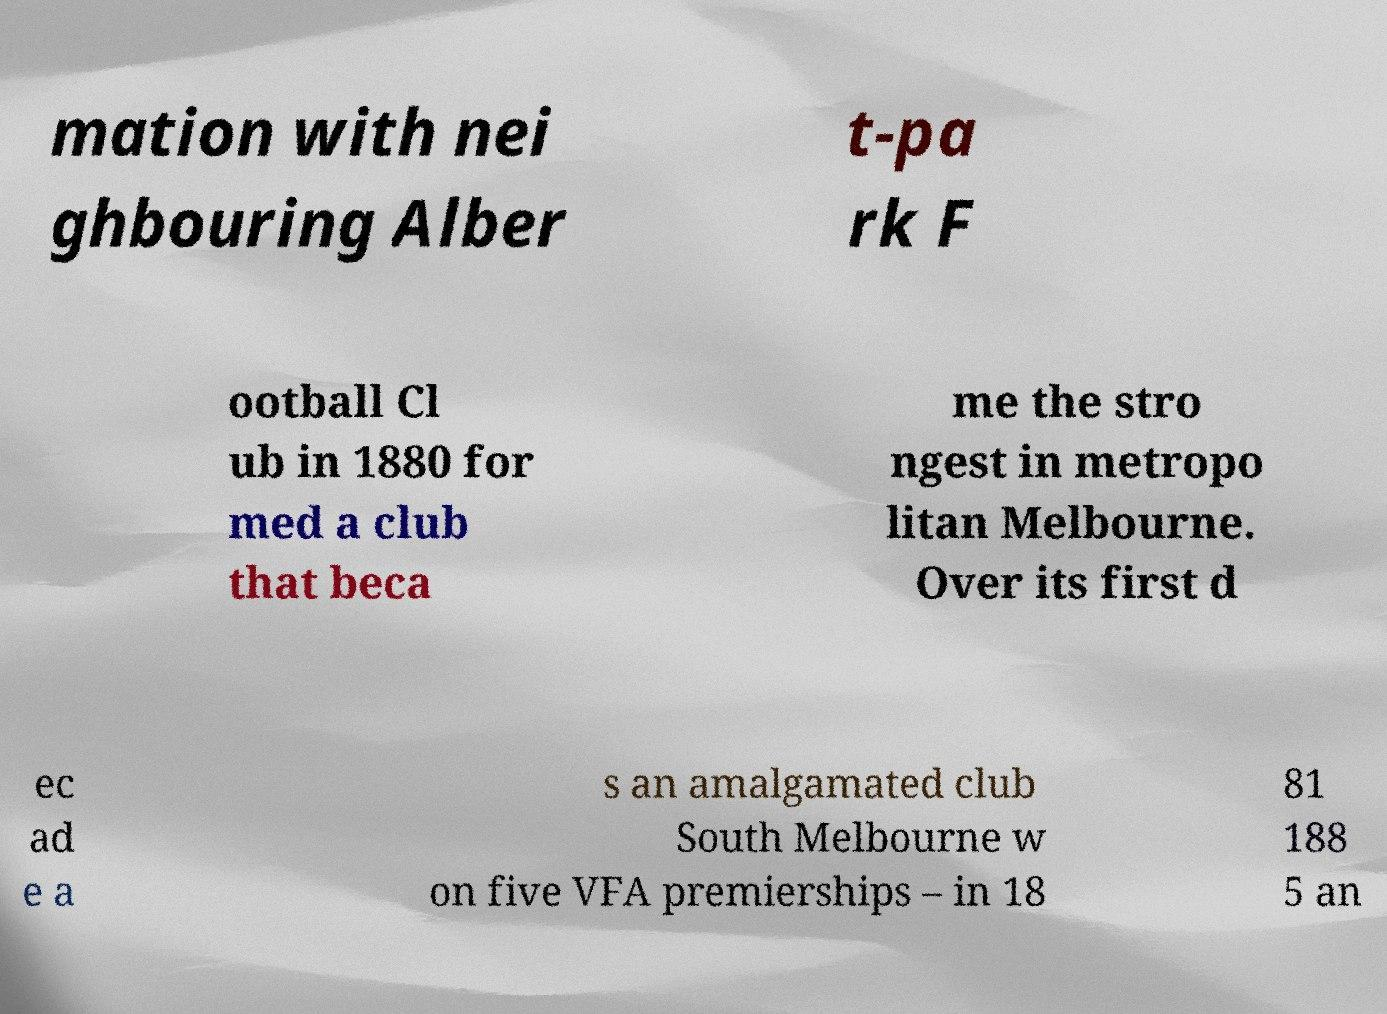Could you extract and type out the text from this image? mation with nei ghbouring Alber t-pa rk F ootball Cl ub in 1880 for med a club that beca me the stro ngest in metropo litan Melbourne. Over its first d ec ad e a s an amalgamated club South Melbourne w on five VFA premierships – in 18 81 188 5 an 